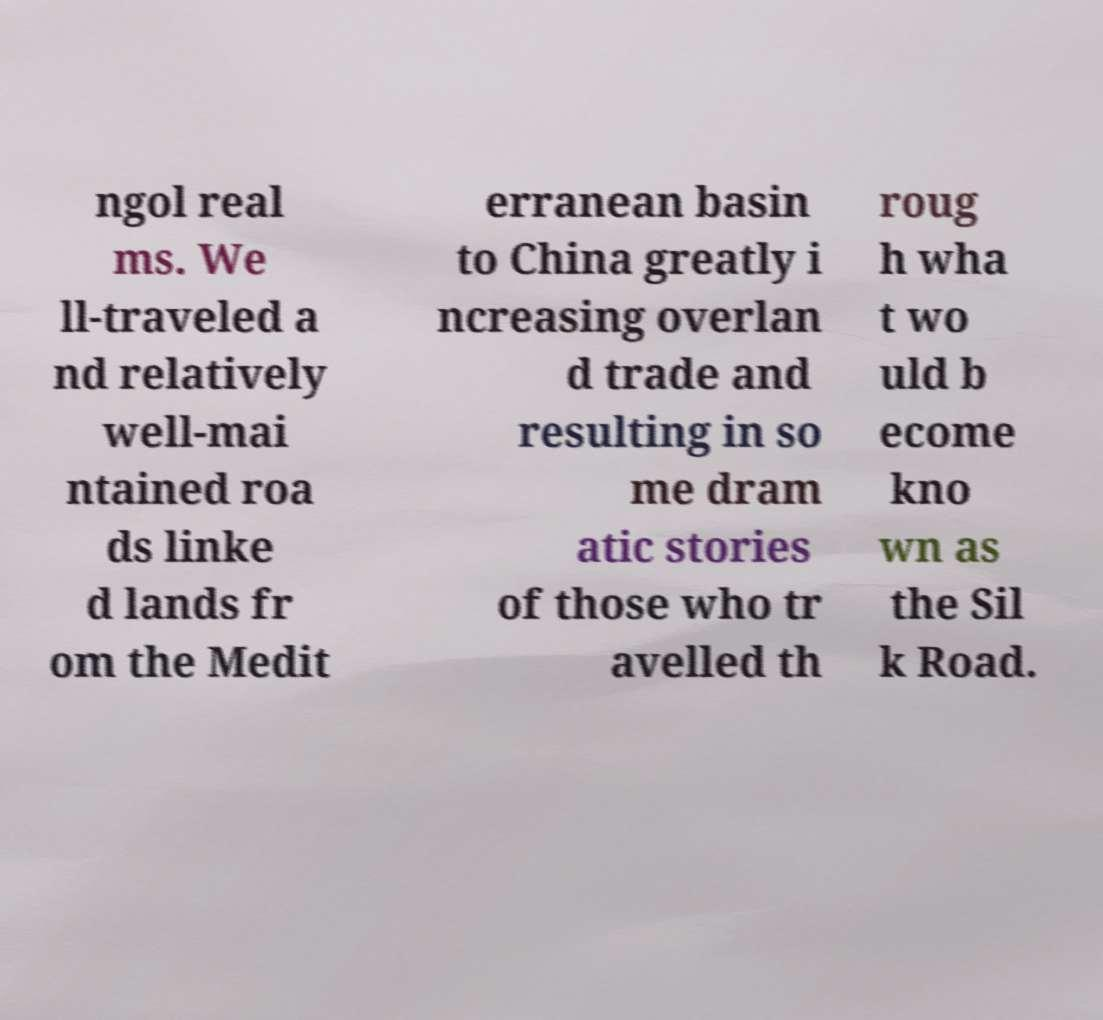Can you accurately transcribe the text from the provided image for me? ngol real ms. We ll-traveled a nd relatively well-mai ntained roa ds linke d lands fr om the Medit erranean basin to China greatly i ncreasing overlan d trade and resulting in so me dram atic stories of those who tr avelled th roug h wha t wo uld b ecome kno wn as the Sil k Road. 